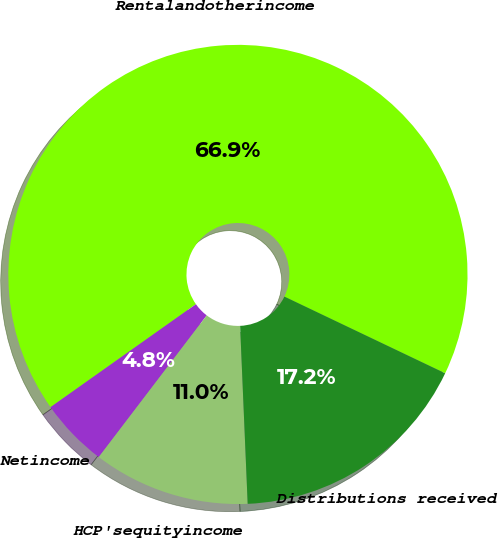Convert chart. <chart><loc_0><loc_0><loc_500><loc_500><pie_chart><fcel>Rentalandotherincome<fcel>Netincome<fcel>HCP'sequityincome<fcel>Distributions received<nl><fcel>66.89%<fcel>4.83%<fcel>11.04%<fcel>17.24%<nl></chart> 